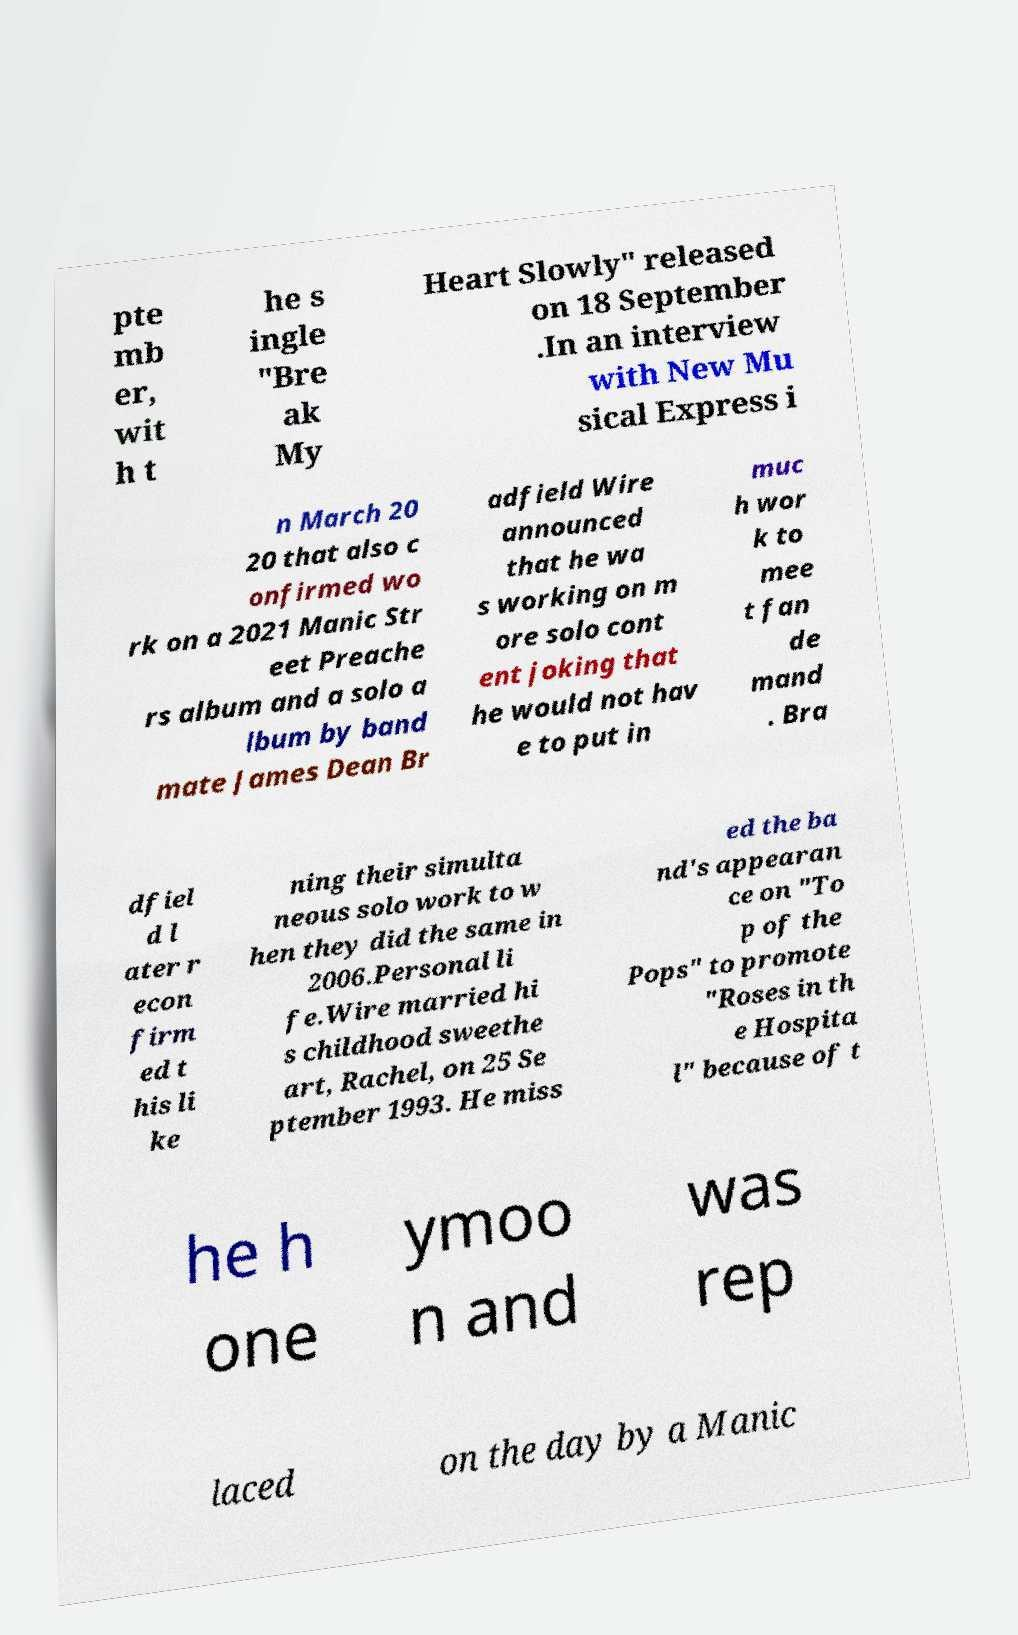There's text embedded in this image that I need extracted. Can you transcribe it verbatim? pte mb er, wit h t he s ingle "Bre ak My Heart Slowly" released on 18 September .In an interview with New Mu sical Express i n March 20 20 that also c onfirmed wo rk on a 2021 Manic Str eet Preache rs album and a solo a lbum by band mate James Dean Br adfield Wire announced that he wa s working on m ore solo cont ent joking that he would not hav e to put in muc h wor k to mee t fan de mand . Bra dfiel d l ater r econ firm ed t his li ke ning their simulta neous solo work to w hen they did the same in 2006.Personal li fe.Wire married hi s childhood sweethe art, Rachel, on 25 Se ptember 1993. He miss ed the ba nd's appearan ce on "To p of the Pops" to promote "Roses in th e Hospita l" because of t he h one ymoo n and was rep laced on the day by a Manic 